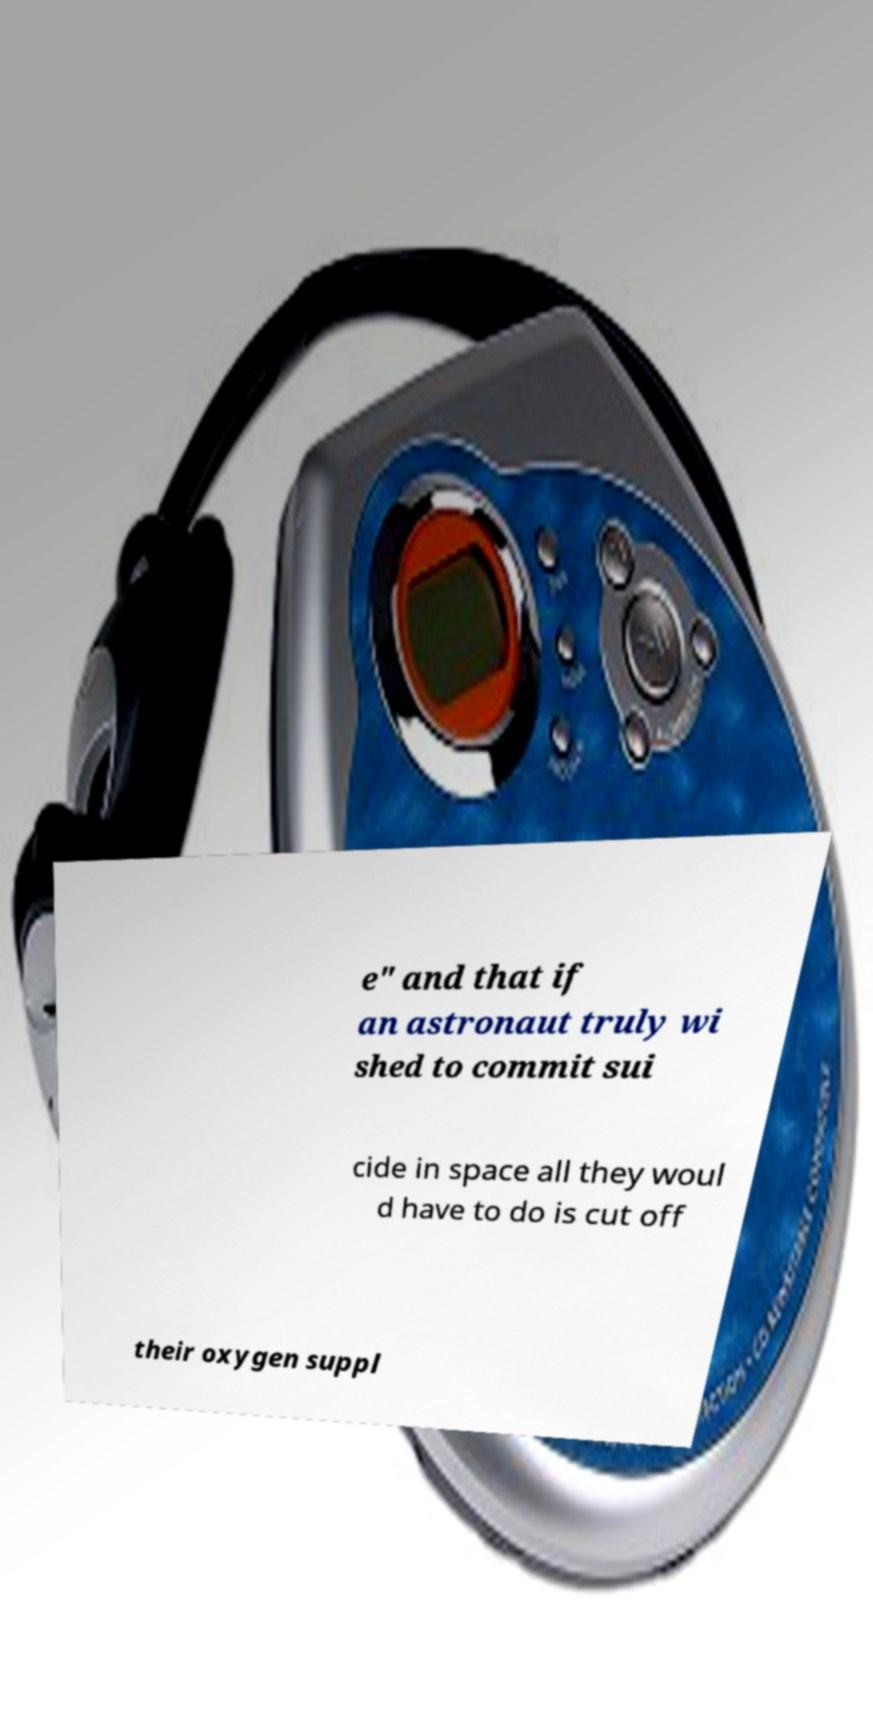Could you assist in decoding the text presented in this image and type it out clearly? e" and that if an astronaut truly wi shed to commit sui cide in space all they woul d have to do is cut off their oxygen suppl 